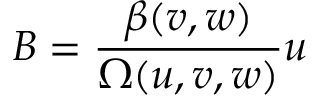<formula> <loc_0><loc_0><loc_500><loc_500>B = \frac { \beta ( v , w ) } { \Omega ( u , v , w ) } u</formula> 